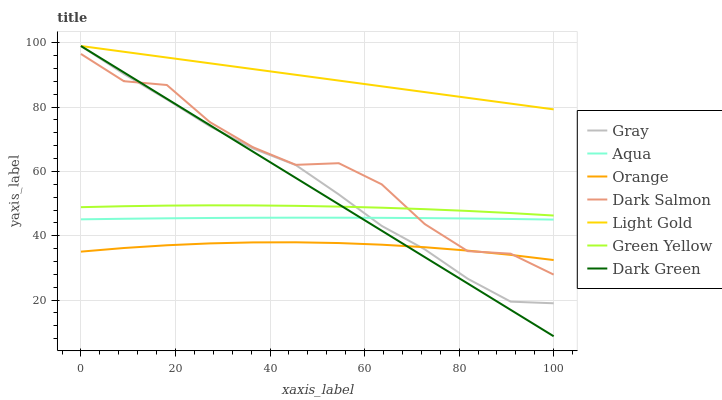Does Orange have the minimum area under the curve?
Answer yes or no. Yes. Does Light Gold have the maximum area under the curve?
Answer yes or no. Yes. Does Aqua have the minimum area under the curve?
Answer yes or no. No. Does Aqua have the maximum area under the curve?
Answer yes or no. No. Is Light Gold the smoothest?
Answer yes or no. Yes. Is Dark Salmon the roughest?
Answer yes or no. Yes. Is Aqua the smoothest?
Answer yes or no. No. Is Aqua the roughest?
Answer yes or no. No. Does Dark Green have the lowest value?
Answer yes or no. Yes. Does Aqua have the lowest value?
Answer yes or no. No. Does Dark Green have the highest value?
Answer yes or no. Yes. Does Aqua have the highest value?
Answer yes or no. No. Is Aqua less than Green Yellow?
Answer yes or no. Yes. Is Green Yellow greater than Aqua?
Answer yes or no. Yes. Does Light Gold intersect Dark Green?
Answer yes or no. Yes. Is Light Gold less than Dark Green?
Answer yes or no. No. Is Light Gold greater than Dark Green?
Answer yes or no. No. Does Aqua intersect Green Yellow?
Answer yes or no. No. 